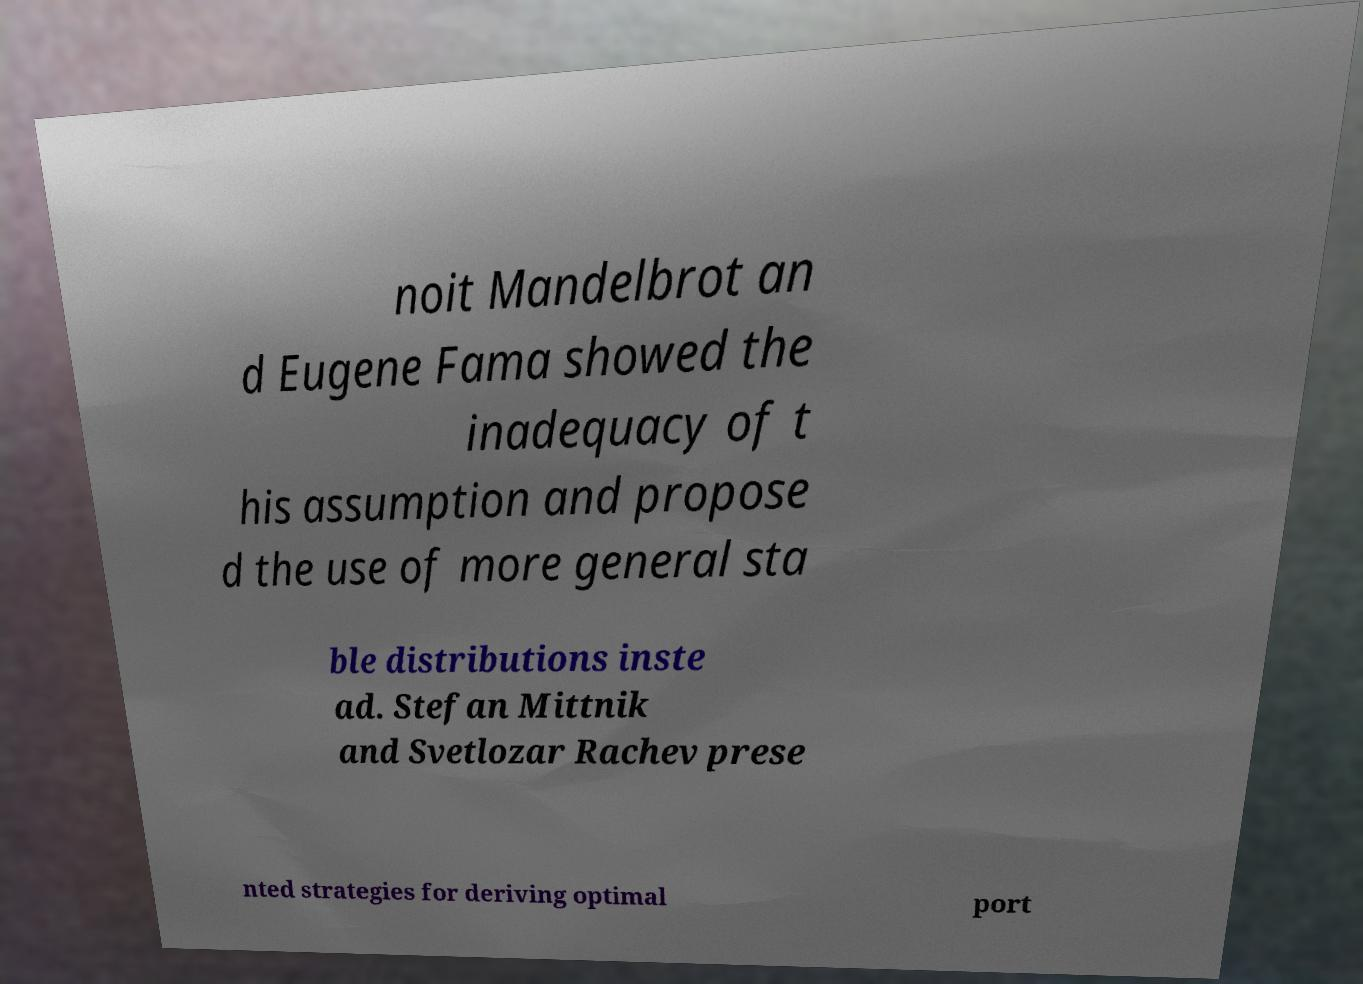For documentation purposes, I need the text within this image transcribed. Could you provide that? noit Mandelbrot an d Eugene Fama showed the inadequacy of t his assumption and propose d the use of more general sta ble distributions inste ad. Stefan Mittnik and Svetlozar Rachev prese nted strategies for deriving optimal port 